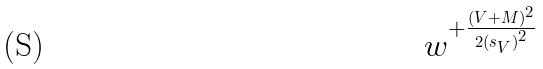<formula> <loc_0><loc_0><loc_500><loc_500>w ^ { + \frac { ( V + M ) ^ { 2 } } { 2 { ( s _ { V } ) } ^ { 2 } } }</formula> 